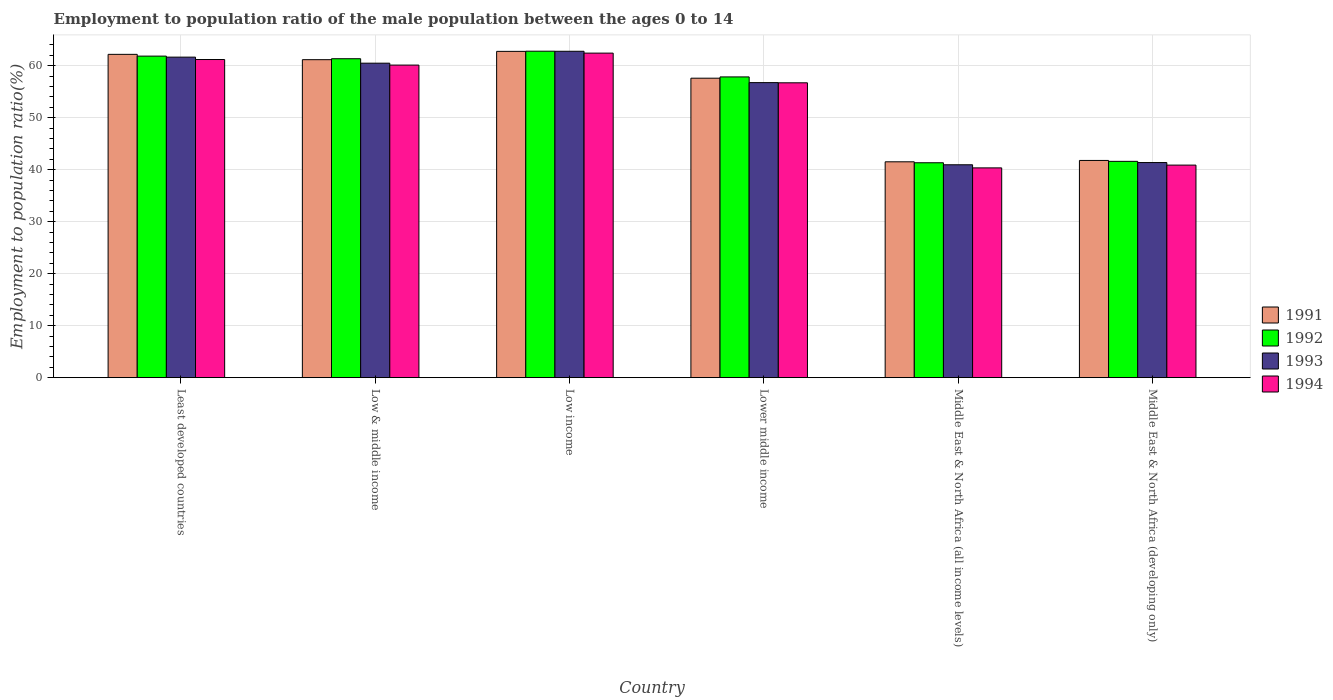How many different coloured bars are there?
Keep it short and to the point. 4. Are the number of bars per tick equal to the number of legend labels?
Give a very brief answer. Yes. Are the number of bars on each tick of the X-axis equal?
Provide a succinct answer. Yes. How many bars are there on the 6th tick from the right?
Keep it short and to the point. 4. In how many cases, is the number of bars for a given country not equal to the number of legend labels?
Offer a very short reply. 0. What is the employment to population ratio in 1991 in Middle East & North Africa (all income levels)?
Your answer should be compact. 41.51. Across all countries, what is the maximum employment to population ratio in 1992?
Your answer should be compact. 62.78. Across all countries, what is the minimum employment to population ratio in 1991?
Offer a terse response. 41.51. In which country was the employment to population ratio in 1992 minimum?
Provide a short and direct response. Middle East & North Africa (all income levels). What is the total employment to population ratio in 1994 in the graph?
Give a very brief answer. 321.62. What is the difference between the employment to population ratio in 1992 in Middle East & North Africa (all income levels) and that in Middle East & North Africa (developing only)?
Your answer should be compact. -0.27. What is the difference between the employment to population ratio in 1993 in Lower middle income and the employment to population ratio in 1992 in Middle East & North Africa (all income levels)?
Make the answer very short. 15.41. What is the average employment to population ratio in 1992 per country?
Provide a succinct answer. 54.45. What is the difference between the employment to population ratio of/in 1992 and employment to population ratio of/in 1991 in Lower middle income?
Your answer should be very brief. 0.25. In how many countries, is the employment to population ratio in 1991 greater than 20 %?
Offer a terse response. 6. What is the ratio of the employment to population ratio in 1992 in Lower middle income to that in Middle East & North Africa (all income levels)?
Make the answer very short. 1.4. Is the employment to population ratio in 1992 in Low income less than that in Middle East & North Africa (all income levels)?
Keep it short and to the point. No. Is the difference between the employment to population ratio in 1992 in Least developed countries and Middle East & North Africa (all income levels) greater than the difference between the employment to population ratio in 1991 in Least developed countries and Middle East & North Africa (all income levels)?
Offer a terse response. No. What is the difference between the highest and the second highest employment to population ratio in 1993?
Give a very brief answer. -1.16. What is the difference between the highest and the lowest employment to population ratio in 1992?
Your response must be concise. 21.45. In how many countries, is the employment to population ratio in 1992 greater than the average employment to population ratio in 1992 taken over all countries?
Keep it short and to the point. 4. Is the sum of the employment to population ratio in 1994 in Low & middle income and Low income greater than the maximum employment to population ratio in 1993 across all countries?
Keep it short and to the point. Yes. Is it the case that in every country, the sum of the employment to population ratio in 1994 and employment to population ratio in 1991 is greater than the sum of employment to population ratio in 1992 and employment to population ratio in 1993?
Ensure brevity in your answer.  No. What does the 1st bar from the left in Low income represents?
Your answer should be very brief. 1991. What does the 1st bar from the right in Middle East & North Africa (developing only) represents?
Your answer should be compact. 1994. Is it the case that in every country, the sum of the employment to population ratio in 1994 and employment to population ratio in 1993 is greater than the employment to population ratio in 1991?
Give a very brief answer. Yes. Are all the bars in the graph horizontal?
Offer a very short reply. No. Are the values on the major ticks of Y-axis written in scientific E-notation?
Provide a succinct answer. No. Where does the legend appear in the graph?
Keep it short and to the point. Center right. What is the title of the graph?
Keep it short and to the point. Employment to population ratio of the male population between the ages 0 to 14. What is the label or title of the X-axis?
Ensure brevity in your answer.  Country. What is the label or title of the Y-axis?
Offer a terse response. Employment to population ratio(%). What is the Employment to population ratio(%) of 1991 in Least developed countries?
Keep it short and to the point. 62.17. What is the Employment to population ratio(%) in 1992 in Least developed countries?
Offer a very short reply. 61.83. What is the Employment to population ratio(%) of 1993 in Least developed countries?
Keep it short and to the point. 61.64. What is the Employment to population ratio(%) in 1994 in Least developed countries?
Give a very brief answer. 61.18. What is the Employment to population ratio(%) of 1991 in Low & middle income?
Ensure brevity in your answer.  61.15. What is the Employment to population ratio(%) of 1992 in Low & middle income?
Your answer should be compact. 61.33. What is the Employment to population ratio(%) in 1993 in Low & middle income?
Your answer should be compact. 60.48. What is the Employment to population ratio(%) in 1994 in Low & middle income?
Provide a short and direct response. 60.11. What is the Employment to population ratio(%) of 1991 in Low income?
Your answer should be very brief. 62.75. What is the Employment to population ratio(%) of 1992 in Low income?
Provide a short and direct response. 62.78. What is the Employment to population ratio(%) of 1993 in Low income?
Your answer should be compact. 62.77. What is the Employment to population ratio(%) in 1994 in Low income?
Ensure brevity in your answer.  62.41. What is the Employment to population ratio(%) of 1991 in Lower middle income?
Ensure brevity in your answer.  57.59. What is the Employment to population ratio(%) of 1992 in Lower middle income?
Give a very brief answer. 57.83. What is the Employment to population ratio(%) of 1993 in Lower middle income?
Provide a succinct answer. 56.74. What is the Employment to population ratio(%) in 1994 in Lower middle income?
Provide a succinct answer. 56.7. What is the Employment to population ratio(%) in 1991 in Middle East & North Africa (all income levels)?
Keep it short and to the point. 41.51. What is the Employment to population ratio(%) of 1992 in Middle East & North Africa (all income levels)?
Make the answer very short. 41.33. What is the Employment to population ratio(%) in 1993 in Middle East & North Africa (all income levels)?
Ensure brevity in your answer.  40.94. What is the Employment to population ratio(%) in 1994 in Middle East & North Africa (all income levels)?
Your answer should be compact. 40.34. What is the Employment to population ratio(%) of 1991 in Middle East & North Africa (developing only)?
Your response must be concise. 41.77. What is the Employment to population ratio(%) in 1992 in Middle East & North Africa (developing only)?
Provide a succinct answer. 41.6. What is the Employment to population ratio(%) of 1993 in Middle East & North Africa (developing only)?
Offer a very short reply. 41.37. What is the Employment to population ratio(%) of 1994 in Middle East & North Africa (developing only)?
Provide a succinct answer. 40.87. Across all countries, what is the maximum Employment to population ratio(%) in 1991?
Your answer should be very brief. 62.75. Across all countries, what is the maximum Employment to population ratio(%) of 1992?
Provide a short and direct response. 62.78. Across all countries, what is the maximum Employment to population ratio(%) of 1993?
Ensure brevity in your answer.  62.77. Across all countries, what is the maximum Employment to population ratio(%) of 1994?
Keep it short and to the point. 62.41. Across all countries, what is the minimum Employment to population ratio(%) in 1991?
Offer a terse response. 41.51. Across all countries, what is the minimum Employment to population ratio(%) in 1992?
Offer a terse response. 41.33. Across all countries, what is the minimum Employment to population ratio(%) in 1993?
Offer a terse response. 40.94. Across all countries, what is the minimum Employment to population ratio(%) in 1994?
Your answer should be very brief. 40.34. What is the total Employment to population ratio(%) in 1991 in the graph?
Make the answer very short. 326.94. What is the total Employment to population ratio(%) in 1992 in the graph?
Provide a short and direct response. 326.7. What is the total Employment to population ratio(%) of 1993 in the graph?
Offer a very short reply. 323.92. What is the total Employment to population ratio(%) in 1994 in the graph?
Provide a succinct answer. 321.62. What is the difference between the Employment to population ratio(%) of 1991 in Least developed countries and that in Low & middle income?
Offer a very short reply. 1.02. What is the difference between the Employment to population ratio(%) in 1992 in Least developed countries and that in Low & middle income?
Offer a very short reply. 0.5. What is the difference between the Employment to population ratio(%) in 1993 in Least developed countries and that in Low & middle income?
Provide a succinct answer. 1.16. What is the difference between the Employment to population ratio(%) of 1994 in Least developed countries and that in Low & middle income?
Provide a succinct answer. 1.07. What is the difference between the Employment to population ratio(%) in 1991 in Least developed countries and that in Low income?
Your answer should be compact. -0.57. What is the difference between the Employment to population ratio(%) in 1992 in Least developed countries and that in Low income?
Offer a very short reply. -0.95. What is the difference between the Employment to population ratio(%) of 1993 in Least developed countries and that in Low income?
Ensure brevity in your answer.  -1.13. What is the difference between the Employment to population ratio(%) in 1994 in Least developed countries and that in Low income?
Provide a short and direct response. -1.23. What is the difference between the Employment to population ratio(%) in 1991 in Least developed countries and that in Lower middle income?
Provide a short and direct response. 4.58. What is the difference between the Employment to population ratio(%) in 1992 in Least developed countries and that in Lower middle income?
Provide a short and direct response. 4. What is the difference between the Employment to population ratio(%) in 1993 in Least developed countries and that in Lower middle income?
Your answer should be very brief. 4.9. What is the difference between the Employment to population ratio(%) of 1994 in Least developed countries and that in Lower middle income?
Offer a very short reply. 4.48. What is the difference between the Employment to population ratio(%) of 1991 in Least developed countries and that in Middle East & North Africa (all income levels)?
Your answer should be very brief. 20.66. What is the difference between the Employment to population ratio(%) in 1992 in Least developed countries and that in Middle East & North Africa (all income levels)?
Provide a short and direct response. 20.51. What is the difference between the Employment to population ratio(%) of 1993 in Least developed countries and that in Middle East & North Africa (all income levels)?
Provide a short and direct response. 20.7. What is the difference between the Employment to population ratio(%) of 1994 in Least developed countries and that in Middle East & North Africa (all income levels)?
Offer a terse response. 20.84. What is the difference between the Employment to population ratio(%) of 1991 in Least developed countries and that in Middle East & North Africa (developing only)?
Keep it short and to the point. 20.4. What is the difference between the Employment to population ratio(%) in 1992 in Least developed countries and that in Middle East & North Africa (developing only)?
Provide a short and direct response. 20.24. What is the difference between the Employment to population ratio(%) of 1993 in Least developed countries and that in Middle East & North Africa (developing only)?
Offer a terse response. 20.27. What is the difference between the Employment to population ratio(%) in 1994 in Least developed countries and that in Middle East & North Africa (developing only)?
Keep it short and to the point. 20.31. What is the difference between the Employment to population ratio(%) of 1991 in Low & middle income and that in Low income?
Ensure brevity in your answer.  -1.6. What is the difference between the Employment to population ratio(%) in 1992 in Low & middle income and that in Low income?
Your answer should be very brief. -1.45. What is the difference between the Employment to population ratio(%) of 1993 in Low & middle income and that in Low income?
Give a very brief answer. -2.29. What is the difference between the Employment to population ratio(%) in 1994 in Low & middle income and that in Low income?
Keep it short and to the point. -2.3. What is the difference between the Employment to population ratio(%) of 1991 in Low & middle income and that in Lower middle income?
Provide a succinct answer. 3.56. What is the difference between the Employment to population ratio(%) of 1992 in Low & middle income and that in Lower middle income?
Your response must be concise. 3.5. What is the difference between the Employment to population ratio(%) in 1993 in Low & middle income and that in Lower middle income?
Provide a short and direct response. 3.74. What is the difference between the Employment to population ratio(%) of 1994 in Low & middle income and that in Lower middle income?
Provide a succinct answer. 3.41. What is the difference between the Employment to population ratio(%) of 1991 in Low & middle income and that in Middle East & North Africa (all income levels)?
Your answer should be very brief. 19.64. What is the difference between the Employment to population ratio(%) in 1992 in Low & middle income and that in Middle East & North Africa (all income levels)?
Your answer should be compact. 20.01. What is the difference between the Employment to population ratio(%) in 1993 in Low & middle income and that in Middle East & North Africa (all income levels)?
Your response must be concise. 19.54. What is the difference between the Employment to population ratio(%) of 1994 in Low & middle income and that in Middle East & North Africa (all income levels)?
Give a very brief answer. 19.77. What is the difference between the Employment to population ratio(%) in 1991 in Low & middle income and that in Middle East & North Africa (developing only)?
Keep it short and to the point. 19.38. What is the difference between the Employment to population ratio(%) of 1992 in Low & middle income and that in Middle East & North Africa (developing only)?
Your answer should be very brief. 19.74. What is the difference between the Employment to population ratio(%) of 1993 in Low & middle income and that in Middle East & North Africa (developing only)?
Your answer should be very brief. 19.11. What is the difference between the Employment to population ratio(%) in 1994 in Low & middle income and that in Middle East & North Africa (developing only)?
Make the answer very short. 19.23. What is the difference between the Employment to population ratio(%) of 1991 in Low income and that in Lower middle income?
Offer a very short reply. 5.16. What is the difference between the Employment to population ratio(%) in 1992 in Low income and that in Lower middle income?
Make the answer very short. 4.95. What is the difference between the Employment to population ratio(%) in 1993 in Low income and that in Lower middle income?
Your answer should be compact. 6.03. What is the difference between the Employment to population ratio(%) of 1994 in Low income and that in Lower middle income?
Offer a terse response. 5.71. What is the difference between the Employment to population ratio(%) in 1991 in Low income and that in Middle East & North Africa (all income levels)?
Your response must be concise. 21.24. What is the difference between the Employment to population ratio(%) in 1992 in Low income and that in Middle East & North Africa (all income levels)?
Your answer should be very brief. 21.45. What is the difference between the Employment to population ratio(%) of 1993 in Low income and that in Middle East & North Africa (all income levels)?
Provide a short and direct response. 21.83. What is the difference between the Employment to population ratio(%) in 1994 in Low income and that in Middle East & North Africa (all income levels)?
Provide a short and direct response. 22.07. What is the difference between the Employment to population ratio(%) of 1991 in Low income and that in Middle East & North Africa (developing only)?
Your response must be concise. 20.97. What is the difference between the Employment to population ratio(%) in 1992 in Low income and that in Middle East & North Africa (developing only)?
Offer a terse response. 21.18. What is the difference between the Employment to population ratio(%) in 1993 in Low income and that in Middle East & North Africa (developing only)?
Keep it short and to the point. 21.4. What is the difference between the Employment to population ratio(%) in 1994 in Low income and that in Middle East & North Africa (developing only)?
Give a very brief answer. 21.54. What is the difference between the Employment to population ratio(%) of 1991 in Lower middle income and that in Middle East & North Africa (all income levels)?
Your response must be concise. 16.08. What is the difference between the Employment to population ratio(%) of 1992 in Lower middle income and that in Middle East & North Africa (all income levels)?
Offer a terse response. 16.51. What is the difference between the Employment to population ratio(%) of 1993 in Lower middle income and that in Middle East & North Africa (all income levels)?
Offer a very short reply. 15.8. What is the difference between the Employment to population ratio(%) of 1994 in Lower middle income and that in Middle East & North Africa (all income levels)?
Your answer should be very brief. 16.36. What is the difference between the Employment to population ratio(%) in 1991 in Lower middle income and that in Middle East & North Africa (developing only)?
Offer a very short reply. 15.82. What is the difference between the Employment to population ratio(%) in 1992 in Lower middle income and that in Middle East & North Africa (developing only)?
Keep it short and to the point. 16.24. What is the difference between the Employment to population ratio(%) in 1993 in Lower middle income and that in Middle East & North Africa (developing only)?
Provide a succinct answer. 15.37. What is the difference between the Employment to population ratio(%) of 1994 in Lower middle income and that in Middle East & North Africa (developing only)?
Give a very brief answer. 15.83. What is the difference between the Employment to population ratio(%) of 1991 in Middle East & North Africa (all income levels) and that in Middle East & North Africa (developing only)?
Your response must be concise. -0.26. What is the difference between the Employment to population ratio(%) in 1992 in Middle East & North Africa (all income levels) and that in Middle East & North Africa (developing only)?
Your response must be concise. -0.27. What is the difference between the Employment to population ratio(%) of 1993 in Middle East & North Africa (all income levels) and that in Middle East & North Africa (developing only)?
Give a very brief answer. -0.43. What is the difference between the Employment to population ratio(%) in 1994 in Middle East & North Africa (all income levels) and that in Middle East & North Africa (developing only)?
Your answer should be very brief. -0.53. What is the difference between the Employment to population ratio(%) of 1991 in Least developed countries and the Employment to population ratio(%) of 1992 in Low & middle income?
Ensure brevity in your answer.  0.84. What is the difference between the Employment to population ratio(%) in 1991 in Least developed countries and the Employment to population ratio(%) in 1993 in Low & middle income?
Your answer should be very brief. 1.7. What is the difference between the Employment to population ratio(%) of 1991 in Least developed countries and the Employment to population ratio(%) of 1994 in Low & middle income?
Give a very brief answer. 2.06. What is the difference between the Employment to population ratio(%) of 1992 in Least developed countries and the Employment to population ratio(%) of 1993 in Low & middle income?
Offer a terse response. 1.36. What is the difference between the Employment to population ratio(%) in 1992 in Least developed countries and the Employment to population ratio(%) in 1994 in Low & middle income?
Provide a succinct answer. 1.73. What is the difference between the Employment to population ratio(%) of 1993 in Least developed countries and the Employment to population ratio(%) of 1994 in Low & middle income?
Your answer should be compact. 1.53. What is the difference between the Employment to population ratio(%) in 1991 in Least developed countries and the Employment to population ratio(%) in 1992 in Low income?
Provide a short and direct response. -0.61. What is the difference between the Employment to population ratio(%) of 1991 in Least developed countries and the Employment to population ratio(%) of 1993 in Low income?
Your answer should be compact. -0.59. What is the difference between the Employment to population ratio(%) in 1991 in Least developed countries and the Employment to population ratio(%) in 1994 in Low income?
Ensure brevity in your answer.  -0.24. What is the difference between the Employment to population ratio(%) of 1992 in Least developed countries and the Employment to population ratio(%) of 1993 in Low income?
Make the answer very short. -0.93. What is the difference between the Employment to population ratio(%) of 1992 in Least developed countries and the Employment to population ratio(%) of 1994 in Low income?
Offer a very short reply. -0.58. What is the difference between the Employment to population ratio(%) in 1993 in Least developed countries and the Employment to population ratio(%) in 1994 in Low income?
Give a very brief answer. -0.77. What is the difference between the Employment to population ratio(%) of 1991 in Least developed countries and the Employment to population ratio(%) of 1992 in Lower middle income?
Offer a terse response. 4.34. What is the difference between the Employment to population ratio(%) in 1991 in Least developed countries and the Employment to population ratio(%) in 1993 in Lower middle income?
Your answer should be very brief. 5.43. What is the difference between the Employment to population ratio(%) in 1991 in Least developed countries and the Employment to population ratio(%) in 1994 in Lower middle income?
Provide a short and direct response. 5.47. What is the difference between the Employment to population ratio(%) of 1992 in Least developed countries and the Employment to population ratio(%) of 1993 in Lower middle income?
Your answer should be very brief. 5.1. What is the difference between the Employment to population ratio(%) in 1992 in Least developed countries and the Employment to population ratio(%) in 1994 in Lower middle income?
Ensure brevity in your answer.  5.13. What is the difference between the Employment to population ratio(%) of 1993 in Least developed countries and the Employment to population ratio(%) of 1994 in Lower middle income?
Give a very brief answer. 4.94. What is the difference between the Employment to population ratio(%) of 1991 in Least developed countries and the Employment to population ratio(%) of 1992 in Middle East & North Africa (all income levels)?
Keep it short and to the point. 20.84. What is the difference between the Employment to population ratio(%) of 1991 in Least developed countries and the Employment to population ratio(%) of 1993 in Middle East & North Africa (all income levels)?
Ensure brevity in your answer.  21.23. What is the difference between the Employment to population ratio(%) in 1991 in Least developed countries and the Employment to population ratio(%) in 1994 in Middle East & North Africa (all income levels)?
Your answer should be compact. 21.83. What is the difference between the Employment to population ratio(%) of 1992 in Least developed countries and the Employment to population ratio(%) of 1993 in Middle East & North Africa (all income levels)?
Offer a terse response. 20.9. What is the difference between the Employment to population ratio(%) in 1992 in Least developed countries and the Employment to population ratio(%) in 1994 in Middle East & North Africa (all income levels)?
Offer a very short reply. 21.49. What is the difference between the Employment to population ratio(%) in 1993 in Least developed countries and the Employment to population ratio(%) in 1994 in Middle East & North Africa (all income levels)?
Keep it short and to the point. 21.3. What is the difference between the Employment to population ratio(%) in 1991 in Least developed countries and the Employment to population ratio(%) in 1992 in Middle East & North Africa (developing only)?
Provide a short and direct response. 20.58. What is the difference between the Employment to population ratio(%) in 1991 in Least developed countries and the Employment to population ratio(%) in 1993 in Middle East & North Africa (developing only)?
Make the answer very short. 20.81. What is the difference between the Employment to population ratio(%) of 1991 in Least developed countries and the Employment to population ratio(%) of 1994 in Middle East & North Africa (developing only)?
Your answer should be very brief. 21.3. What is the difference between the Employment to population ratio(%) of 1992 in Least developed countries and the Employment to population ratio(%) of 1993 in Middle East & North Africa (developing only)?
Your answer should be very brief. 20.47. What is the difference between the Employment to population ratio(%) in 1992 in Least developed countries and the Employment to population ratio(%) in 1994 in Middle East & North Africa (developing only)?
Offer a terse response. 20.96. What is the difference between the Employment to population ratio(%) of 1993 in Least developed countries and the Employment to population ratio(%) of 1994 in Middle East & North Africa (developing only)?
Ensure brevity in your answer.  20.76. What is the difference between the Employment to population ratio(%) in 1991 in Low & middle income and the Employment to population ratio(%) in 1992 in Low income?
Provide a succinct answer. -1.63. What is the difference between the Employment to population ratio(%) in 1991 in Low & middle income and the Employment to population ratio(%) in 1993 in Low income?
Offer a terse response. -1.62. What is the difference between the Employment to population ratio(%) of 1991 in Low & middle income and the Employment to population ratio(%) of 1994 in Low income?
Offer a very short reply. -1.26. What is the difference between the Employment to population ratio(%) of 1992 in Low & middle income and the Employment to population ratio(%) of 1993 in Low income?
Ensure brevity in your answer.  -1.43. What is the difference between the Employment to population ratio(%) in 1992 in Low & middle income and the Employment to population ratio(%) in 1994 in Low income?
Make the answer very short. -1.08. What is the difference between the Employment to population ratio(%) in 1993 in Low & middle income and the Employment to population ratio(%) in 1994 in Low income?
Your answer should be very brief. -1.94. What is the difference between the Employment to population ratio(%) of 1991 in Low & middle income and the Employment to population ratio(%) of 1992 in Lower middle income?
Your response must be concise. 3.31. What is the difference between the Employment to population ratio(%) in 1991 in Low & middle income and the Employment to population ratio(%) in 1993 in Lower middle income?
Ensure brevity in your answer.  4.41. What is the difference between the Employment to population ratio(%) of 1991 in Low & middle income and the Employment to population ratio(%) of 1994 in Lower middle income?
Ensure brevity in your answer.  4.45. What is the difference between the Employment to population ratio(%) of 1992 in Low & middle income and the Employment to population ratio(%) of 1993 in Lower middle income?
Your response must be concise. 4.59. What is the difference between the Employment to population ratio(%) of 1992 in Low & middle income and the Employment to population ratio(%) of 1994 in Lower middle income?
Offer a terse response. 4.63. What is the difference between the Employment to population ratio(%) of 1993 in Low & middle income and the Employment to population ratio(%) of 1994 in Lower middle income?
Offer a very short reply. 3.77. What is the difference between the Employment to population ratio(%) of 1991 in Low & middle income and the Employment to population ratio(%) of 1992 in Middle East & North Africa (all income levels)?
Provide a succinct answer. 19.82. What is the difference between the Employment to population ratio(%) in 1991 in Low & middle income and the Employment to population ratio(%) in 1993 in Middle East & North Africa (all income levels)?
Give a very brief answer. 20.21. What is the difference between the Employment to population ratio(%) of 1991 in Low & middle income and the Employment to population ratio(%) of 1994 in Middle East & North Africa (all income levels)?
Provide a succinct answer. 20.81. What is the difference between the Employment to population ratio(%) of 1992 in Low & middle income and the Employment to population ratio(%) of 1993 in Middle East & North Africa (all income levels)?
Offer a terse response. 20.39. What is the difference between the Employment to population ratio(%) of 1992 in Low & middle income and the Employment to population ratio(%) of 1994 in Middle East & North Africa (all income levels)?
Your answer should be very brief. 20.99. What is the difference between the Employment to population ratio(%) of 1993 in Low & middle income and the Employment to population ratio(%) of 1994 in Middle East & North Africa (all income levels)?
Provide a short and direct response. 20.14. What is the difference between the Employment to population ratio(%) of 1991 in Low & middle income and the Employment to population ratio(%) of 1992 in Middle East & North Africa (developing only)?
Ensure brevity in your answer.  19.55. What is the difference between the Employment to population ratio(%) of 1991 in Low & middle income and the Employment to population ratio(%) of 1993 in Middle East & North Africa (developing only)?
Provide a short and direct response. 19.78. What is the difference between the Employment to population ratio(%) in 1991 in Low & middle income and the Employment to population ratio(%) in 1994 in Middle East & North Africa (developing only)?
Offer a very short reply. 20.27. What is the difference between the Employment to population ratio(%) in 1992 in Low & middle income and the Employment to population ratio(%) in 1993 in Middle East & North Africa (developing only)?
Provide a short and direct response. 19.97. What is the difference between the Employment to population ratio(%) of 1992 in Low & middle income and the Employment to population ratio(%) of 1994 in Middle East & North Africa (developing only)?
Offer a very short reply. 20.46. What is the difference between the Employment to population ratio(%) in 1993 in Low & middle income and the Employment to population ratio(%) in 1994 in Middle East & North Africa (developing only)?
Ensure brevity in your answer.  19.6. What is the difference between the Employment to population ratio(%) of 1991 in Low income and the Employment to population ratio(%) of 1992 in Lower middle income?
Your response must be concise. 4.91. What is the difference between the Employment to population ratio(%) in 1991 in Low income and the Employment to population ratio(%) in 1993 in Lower middle income?
Your answer should be very brief. 6.01. What is the difference between the Employment to population ratio(%) of 1991 in Low income and the Employment to population ratio(%) of 1994 in Lower middle income?
Keep it short and to the point. 6.05. What is the difference between the Employment to population ratio(%) in 1992 in Low income and the Employment to population ratio(%) in 1993 in Lower middle income?
Your answer should be compact. 6.04. What is the difference between the Employment to population ratio(%) of 1992 in Low income and the Employment to population ratio(%) of 1994 in Lower middle income?
Make the answer very short. 6.08. What is the difference between the Employment to population ratio(%) in 1993 in Low income and the Employment to population ratio(%) in 1994 in Lower middle income?
Ensure brevity in your answer.  6.06. What is the difference between the Employment to population ratio(%) in 1991 in Low income and the Employment to population ratio(%) in 1992 in Middle East & North Africa (all income levels)?
Offer a very short reply. 21.42. What is the difference between the Employment to population ratio(%) of 1991 in Low income and the Employment to population ratio(%) of 1993 in Middle East & North Africa (all income levels)?
Offer a terse response. 21.81. What is the difference between the Employment to population ratio(%) of 1991 in Low income and the Employment to population ratio(%) of 1994 in Middle East & North Africa (all income levels)?
Your answer should be compact. 22.41. What is the difference between the Employment to population ratio(%) in 1992 in Low income and the Employment to population ratio(%) in 1993 in Middle East & North Africa (all income levels)?
Keep it short and to the point. 21.84. What is the difference between the Employment to population ratio(%) in 1992 in Low income and the Employment to population ratio(%) in 1994 in Middle East & North Africa (all income levels)?
Provide a short and direct response. 22.44. What is the difference between the Employment to population ratio(%) in 1993 in Low income and the Employment to population ratio(%) in 1994 in Middle East & North Africa (all income levels)?
Offer a very short reply. 22.43. What is the difference between the Employment to population ratio(%) of 1991 in Low income and the Employment to population ratio(%) of 1992 in Middle East & North Africa (developing only)?
Give a very brief answer. 21.15. What is the difference between the Employment to population ratio(%) of 1991 in Low income and the Employment to population ratio(%) of 1993 in Middle East & North Africa (developing only)?
Provide a succinct answer. 21.38. What is the difference between the Employment to population ratio(%) in 1991 in Low income and the Employment to population ratio(%) in 1994 in Middle East & North Africa (developing only)?
Provide a short and direct response. 21.87. What is the difference between the Employment to population ratio(%) in 1992 in Low income and the Employment to population ratio(%) in 1993 in Middle East & North Africa (developing only)?
Keep it short and to the point. 21.41. What is the difference between the Employment to population ratio(%) in 1992 in Low income and the Employment to population ratio(%) in 1994 in Middle East & North Africa (developing only)?
Offer a terse response. 21.91. What is the difference between the Employment to population ratio(%) in 1993 in Low income and the Employment to population ratio(%) in 1994 in Middle East & North Africa (developing only)?
Keep it short and to the point. 21.89. What is the difference between the Employment to population ratio(%) in 1991 in Lower middle income and the Employment to population ratio(%) in 1992 in Middle East & North Africa (all income levels)?
Make the answer very short. 16.26. What is the difference between the Employment to population ratio(%) of 1991 in Lower middle income and the Employment to population ratio(%) of 1993 in Middle East & North Africa (all income levels)?
Provide a succinct answer. 16.65. What is the difference between the Employment to population ratio(%) of 1991 in Lower middle income and the Employment to population ratio(%) of 1994 in Middle East & North Africa (all income levels)?
Offer a very short reply. 17.25. What is the difference between the Employment to population ratio(%) in 1992 in Lower middle income and the Employment to population ratio(%) in 1993 in Middle East & North Africa (all income levels)?
Offer a very short reply. 16.9. What is the difference between the Employment to population ratio(%) of 1992 in Lower middle income and the Employment to population ratio(%) of 1994 in Middle East & North Africa (all income levels)?
Offer a very short reply. 17.49. What is the difference between the Employment to population ratio(%) in 1993 in Lower middle income and the Employment to population ratio(%) in 1994 in Middle East & North Africa (all income levels)?
Offer a very short reply. 16.4. What is the difference between the Employment to population ratio(%) in 1991 in Lower middle income and the Employment to population ratio(%) in 1992 in Middle East & North Africa (developing only)?
Offer a very short reply. 15.99. What is the difference between the Employment to population ratio(%) of 1991 in Lower middle income and the Employment to population ratio(%) of 1993 in Middle East & North Africa (developing only)?
Provide a short and direct response. 16.22. What is the difference between the Employment to population ratio(%) of 1991 in Lower middle income and the Employment to population ratio(%) of 1994 in Middle East & North Africa (developing only)?
Your answer should be very brief. 16.71. What is the difference between the Employment to population ratio(%) of 1992 in Lower middle income and the Employment to population ratio(%) of 1993 in Middle East & North Africa (developing only)?
Give a very brief answer. 16.47. What is the difference between the Employment to population ratio(%) of 1992 in Lower middle income and the Employment to population ratio(%) of 1994 in Middle East & North Africa (developing only)?
Your answer should be very brief. 16.96. What is the difference between the Employment to population ratio(%) of 1993 in Lower middle income and the Employment to population ratio(%) of 1994 in Middle East & North Africa (developing only)?
Your response must be concise. 15.86. What is the difference between the Employment to population ratio(%) in 1991 in Middle East & North Africa (all income levels) and the Employment to population ratio(%) in 1992 in Middle East & North Africa (developing only)?
Offer a very short reply. -0.09. What is the difference between the Employment to population ratio(%) in 1991 in Middle East & North Africa (all income levels) and the Employment to population ratio(%) in 1993 in Middle East & North Africa (developing only)?
Your answer should be compact. 0.14. What is the difference between the Employment to population ratio(%) of 1991 in Middle East & North Africa (all income levels) and the Employment to population ratio(%) of 1994 in Middle East & North Africa (developing only)?
Provide a succinct answer. 0.64. What is the difference between the Employment to population ratio(%) of 1992 in Middle East & North Africa (all income levels) and the Employment to population ratio(%) of 1993 in Middle East & North Africa (developing only)?
Your response must be concise. -0.04. What is the difference between the Employment to population ratio(%) in 1992 in Middle East & North Africa (all income levels) and the Employment to population ratio(%) in 1994 in Middle East & North Africa (developing only)?
Your response must be concise. 0.45. What is the difference between the Employment to population ratio(%) of 1993 in Middle East & North Africa (all income levels) and the Employment to population ratio(%) of 1994 in Middle East & North Africa (developing only)?
Your response must be concise. 0.06. What is the average Employment to population ratio(%) of 1991 per country?
Provide a succinct answer. 54.49. What is the average Employment to population ratio(%) in 1992 per country?
Your answer should be very brief. 54.45. What is the average Employment to population ratio(%) in 1993 per country?
Make the answer very short. 53.99. What is the average Employment to population ratio(%) in 1994 per country?
Ensure brevity in your answer.  53.6. What is the difference between the Employment to population ratio(%) of 1991 and Employment to population ratio(%) of 1992 in Least developed countries?
Offer a terse response. 0.34. What is the difference between the Employment to population ratio(%) of 1991 and Employment to population ratio(%) of 1993 in Least developed countries?
Ensure brevity in your answer.  0.54. What is the difference between the Employment to population ratio(%) in 1992 and Employment to population ratio(%) in 1993 in Least developed countries?
Ensure brevity in your answer.  0.2. What is the difference between the Employment to population ratio(%) in 1992 and Employment to population ratio(%) in 1994 in Least developed countries?
Provide a short and direct response. 0.65. What is the difference between the Employment to population ratio(%) of 1993 and Employment to population ratio(%) of 1994 in Least developed countries?
Your response must be concise. 0.46. What is the difference between the Employment to population ratio(%) in 1991 and Employment to population ratio(%) in 1992 in Low & middle income?
Your response must be concise. -0.18. What is the difference between the Employment to population ratio(%) of 1991 and Employment to population ratio(%) of 1993 in Low & middle income?
Provide a short and direct response. 0.67. What is the difference between the Employment to population ratio(%) of 1992 and Employment to population ratio(%) of 1993 in Low & middle income?
Your answer should be very brief. 0.86. What is the difference between the Employment to population ratio(%) in 1992 and Employment to population ratio(%) in 1994 in Low & middle income?
Your response must be concise. 1.22. What is the difference between the Employment to population ratio(%) in 1993 and Employment to population ratio(%) in 1994 in Low & middle income?
Give a very brief answer. 0.37. What is the difference between the Employment to population ratio(%) in 1991 and Employment to population ratio(%) in 1992 in Low income?
Provide a short and direct response. -0.03. What is the difference between the Employment to population ratio(%) in 1991 and Employment to population ratio(%) in 1993 in Low income?
Provide a succinct answer. -0.02. What is the difference between the Employment to population ratio(%) in 1991 and Employment to population ratio(%) in 1994 in Low income?
Your answer should be compact. 0.33. What is the difference between the Employment to population ratio(%) in 1992 and Employment to population ratio(%) in 1993 in Low income?
Offer a very short reply. 0.01. What is the difference between the Employment to population ratio(%) of 1992 and Employment to population ratio(%) of 1994 in Low income?
Offer a terse response. 0.37. What is the difference between the Employment to population ratio(%) in 1993 and Employment to population ratio(%) in 1994 in Low income?
Your response must be concise. 0.35. What is the difference between the Employment to population ratio(%) in 1991 and Employment to population ratio(%) in 1992 in Lower middle income?
Keep it short and to the point. -0.25. What is the difference between the Employment to population ratio(%) in 1991 and Employment to population ratio(%) in 1993 in Lower middle income?
Give a very brief answer. 0.85. What is the difference between the Employment to population ratio(%) of 1991 and Employment to population ratio(%) of 1994 in Lower middle income?
Ensure brevity in your answer.  0.89. What is the difference between the Employment to population ratio(%) in 1992 and Employment to population ratio(%) in 1993 in Lower middle income?
Give a very brief answer. 1.1. What is the difference between the Employment to population ratio(%) of 1992 and Employment to population ratio(%) of 1994 in Lower middle income?
Keep it short and to the point. 1.13. What is the difference between the Employment to population ratio(%) in 1993 and Employment to population ratio(%) in 1994 in Lower middle income?
Your response must be concise. 0.04. What is the difference between the Employment to population ratio(%) in 1991 and Employment to population ratio(%) in 1992 in Middle East & North Africa (all income levels)?
Provide a succinct answer. 0.18. What is the difference between the Employment to population ratio(%) of 1991 and Employment to population ratio(%) of 1993 in Middle East & North Africa (all income levels)?
Provide a succinct answer. 0.57. What is the difference between the Employment to population ratio(%) of 1991 and Employment to population ratio(%) of 1994 in Middle East & North Africa (all income levels)?
Offer a terse response. 1.17. What is the difference between the Employment to population ratio(%) in 1992 and Employment to population ratio(%) in 1993 in Middle East & North Africa (all income levels)?
Your answer should be very brief. 0.39. What is the difference between the Employment to population ratio(%) in 1992 and Employment to population ratio(%) in 1994 in Middle East & North Africa (all income levels)?
Give a very brief answer. 0.99. What is the difference between the Employment to population ratio(%) in 1993 and Employment to population ratio(%) in 1994 in Middle East & North Africa (all income levels)?
Offer a terse response. 0.6. What is the difference between the Employment to population ratio(%) in 1991 and Employment to population ratio(%) in 1992 in Middle East & North Africa (developing only)?
Ensure brevity in your answer.  0.18. What is the difference between the Employment to population ratio(%) in 1991 and Employment to population ratio(%) in 1993 in Middle East & North Africa (developing only)?
Provide a succinct answer. 0.41. What is the difference between the Employment to population ratio(%) of 1991 and Employment to population ratio(%) of 1994 in Middle East & North Africa (developing only)?
Keep it short and to the point. 0.9. What is the difference between the Employment to population ratio(%) in 1992 and Employment to population ratio(%) in 1993 in Middle East & North Africa (developing only)?
Your answer should be compact. 0.23. What is the difference between the Employment to population ratio(%) in 1992 and Employment to population ratio(%) in 1994 in Middle East & North Africa (developing only)?
Provide a succinct answer. 0.72. What is the difference between the Employment to population ratio(%) in 1993 and Employment to population ratio(%) in 1994 in Middle East & North Africa (developing only)?
Offer a terse response. 0.49. What is the ratio of the Employment to population ratio(%) of 1991 in Least developed countries to that in Low & middle income?
Offer a very short reply. 1.02. What is the ratio of the Employment to population ratio(%) in 1992 in Least developed countries to that in Low & middle income?
Your response must be concise. 1.01. What is the ratio of the Employment to population ratio(%) of 1993 in Least developed countries to that in Low & middle income?
Offer a very short reply. 1.02. What is the ratio of the Employment to population ratio(%) of 1994 in Least developed countries to that in Low & middle income?
Provide a succinct answer. 1.02. What is the ratio of the Employment to population ratio(%) in 1991 in Least developed countries to that in Low income?
Your answer should be very brief. 0.99. What is the ratio of the Employment to population ratio(%) in 1992 in Least developed countries to that in Low income?
Your answer should be compact. 0.98. What is the ratio of the Employment to population ratio(%) in 1994 in Least developed countries to that in Low income?
Your answer should be compact. 0.98. What is the ratio of the Employment to population ratio(%) in 1991 in Least developed countries to that in Lower middle income?
Offer a terse response. 1.08. What is the ratio of the Employment to population ratio(%) of 1992 in Least developed countries to that in Lower middle income?
Ensure brevity in your answer.  1.07. What is the ratio of the Employment to population ratio(%) of 1993 in Least developed countries to that in Lower middle income?
Make the answer very short. 1.09. What is the ratio of the Employment to population ratio(%) in 1994 in Least developed countries to that in Lower middle income?
Provide a succinct answer. 1.08. What is the ratio of the Employment to population ratio(%) in 1991 in Least developed countries to that in Middle East & North Africa (all income levels)?
Provide a short and direct response. 1.5. What is the ratio of the Employment to population ratio(%) in 1992 in Least developed countries to that in Middle East & North Africa (all income levels)?
Provide a succinct answer. 1.5. What is the ratio of the Employment to population ratio(%) in 1993 in Least developed countries to that in Middle East & North Africa (all income levels)?
Give a very brief answer. 1.51. What is the ratio of the Employment to population ratio(%) in 1994 in Least developed countries to that in Middle East & North Africa (all income levels)?
Your answer should be very brief. 1.52. What is the ratio of the Employment to population ratio(%) of 1991 in Least developed countries to that in Middle East & North Africa (developing only)?
Provide a succinct answer. 1.49. What is the ratio of the Employment to population ratio(%) of 1992 in Least developed countries to that in Middle East & North Africa (developing only)?
Ensure brevity in your answer.  1.49. What is the ratio of the Employment to population ratio(%) of 1993 in Least developed countries to that in Middle East & North Africa (developing only)?
Provide a short and direct response. 1.49. What is the ratio of the Employment to population ratio(%) in 1994 in Least developed countries to that in Middle East & North Africa (developing only)?
Your answer should be very brief. 1.5. What is the ratio of the Employment to population ratio(%) of 1991 in Low & middle income to that in Low income?
Your response must be concise. 0.97. What is the ratio of the Employment to population ratio(%) of 1993 in Low & middle income to that in Low income?
Offer a very short reply. 0.96. What is the ratio of the Employment to population ratio(%) in 1994 in Low & middle income to that in Low income?
Keep it short and to the point. 0.96. What is the ratio of the Employment to population ratio(%) of 1991 in Low & middle income to that in Lower middle income?
Your answer should be compact. 1.06. What is the ratio of the Employment to population ratio(%) in 1992 in Low & middle income to that in Lower middle income?
Offer a very short reply. 1.06. What is the ratio of the Employment to population ratio(%) of 1993 in Low & middle income to that in Lower middle income?
Keep it short and to the point. 1.07. What is the ratio of the Employment to population ratio(%) of 1994 in Low & middle income to that in Lower middle income?
Your response must be concise. 1.06. What is the ratio of the Employment to population ratio(%) in 1991 in Low & middle income to that in Middle East & North Africa (all income levels)?
Make the answer very short. 1.47. What is the ratio of the Employment to population ratio(%) of 1992 in Low & middle income to that in Middle East & North Africa (all income levels)?
Provide a short and direct response. 1.48. What is the ratio of the Employment to population ratio(%) in 1993 in Low & middle income to that in Middle East & North Africa (all income levels)?
Keep it short and to the point. 1.48. What is the ratio of the Employment to population ratio(%) in 1994 in Low & middle income to that in Middle East & North Africa (all income levels)?
Provide a succinct answer. 1.49. What is the ratio of the Employment to population ratio(%) in 1991 in Low & middle income to that in Middle East & North Africa (developing only)?
Ensure brevity in your answer.  1.46. What is the ratio of the Employment to population ratio(%) in 1992 in Low & middle income to that in Middle East & North Africa (developing only)?
Give a very brief answer. 1.47. What is the ratio of the Employment to population ratio(%) in 1993 in Low & middle income to that in Middle East & North Africa (developing only)?
Give a very brief answer. 1.46. What is the ratio of the Employment to population ratio(%) of 1994 in Low & middle income to that in Middle East & North Africa (developing only)?
Your answer should be very brief. 1.47. What is the ratio of the Employment to population ratio(%) in 1991 in Low income to that in Lower middle income?
Provide a succinct answer. 1.09. What is the ratio of the Employment to population ratio(%) in 1992 in Low income to that in Lower middle income?
Provide a succinct answer. 1.09. What is the ratio of the Employment to population ratio(%) of 1993 in Low income to that in Lower middle income?
Ensure brevity in your answer.  1.11. What is the ratio of the Employment to population ratio(%) in 1994 in Low income to that in Lower middle income?
Ensure brevity in your answer.  1.1. What is the ratio of the Employment to population ratio(%) in 1991 in Low income to that in Middle East & North Africa (all income levels)?
Keep it short and to the point. 1.51. What is the ratio of the Employment to population ratio(%) in 1992 in Low income to that in Middle East & North Africa (all income levels)?
Make the answer very short. 1.52. What is the ratio of the Employment to population ratio(%) of 1993 in Low income to that in Middle East & North Africa (all income levels)?
Make the answer very short. 1.53. What is the ratio of the Employment to population ratio(%) of 1994 in Low income to that in Middle East & North Africa (all income levels)?
Your answer should be very brief. 1.55. What is the ratio of the Employment to population ratio(%) in 1991 in Low income to that in Middle East & North Africa (developing only)?
Give a very brief answer. 1.5. What is the ratio of the Employment to population ratio(%) in 1992 in Low income to that in Middle East & North Africa (developing only)?
Give a very brief answer. 1.51. What is the ratio of the Employment to population ratio(%) of 1993 in Low income to that in Middle East & North Africa (developing only)?
Offer a terse response. 1.52. What is the ratio of the Employment to population ratio(%) of 1994 in Low income to that in Middle East & North Africa (developing only)?
Provide a short and direct response. 1.53. What is the ratio of the Employment to population ratio(%) of 1991 in Lower middle income to that in Middle East & North Africa (all income levels)?
Your answer should be very brief. 1.39. What is the ratio of the Employment to population ratio(%) in 1992 in Lower middle income to that in Middle East & North Africa (all income levels)?
Provide a succinct answer. 1.4. What is the ratio of the Employment to population ratio(%) of 1993 in Lower middle income to that in Middle East & North Africa (all income levels)?
Your answer should be compact. 1.39. What is the ratio of the Employment to population ratio(%) of 1994 in Lower middle income to that in Middle East & North Africa (all income levels)?
Your answer should be very brief. 1.41. What is the ratio of the Employment to population ratio(%) of 1991 in Lower middle income to that in Middle East & North Africa (developing only)?
Give a very brief answer. 1.38. What is the ratio of the Employment to population ratio(%) of 1992 in Lower middle income to that in Middle East & North Africa (developing only)?
Keep it short and to the point. 1.39. What is the ratio of the Employment to population ratio(%) of 1993 in Lower middle income to that in Middle East & North Africa (developing only)?
Provide a succinct answer. 1.37. What is the ratio of the Employment to population ratio(%) in 1994 in Lower middle income to that in Middle East & North Africa (developing only)?
Give a very brief answer. 1.39. What is the ratio of the Employment to population ratio(%) of 1992 in Middle East & North Africa (all income levels) to that in Middle East & North Africa (developing only)?
Offer a terse response. 0.99. What is the ratio of the Employment to population ratio(%) in 1993 in Middle East & North Africa (all income levels) to that in Middle East & North Africa (developing only)?
Make the answer very short. 0.99. What is the ratio of the Employment to population ratio(%) of 1994 in Middle East & North Africa (all income levels) to that in Middle East & North Africa (developing only)?
Offer a very short reply. 0.99. What is the difference between the highest and the second highest Employment to population ratio(%) in 1991?
Keep it short and to the point. 0.57. What is the difference between the highest and the second highest Employment to population ratio(%) in 1992?
Your answer should be compact. 0.95. What is the difference between the highest and the second highest Employment to population ratio(%) of 1993?
Your response must be concise. 1.13. What is the difference between the highest and the second highest Employment to population ratio(%) of 1994?
Offer a very short reply. 1.23. What is the difference between the highest and the lowest Employment to population ratio(%) in 1991?
Make the answer very short. 21.24. What is the difference between the highest and the lowest Employment to population ratio(%) of 1992?
Give a very brief answer. 21.45. What is the difference between the highest and the lowest Employment to population ratio(%) of 1993?
Make the answer very short. 21.83. What is the difference between the highest and the lowest Employment to population ratio(%) in 1994?
Ensure brevity in your answer.  22.07. 